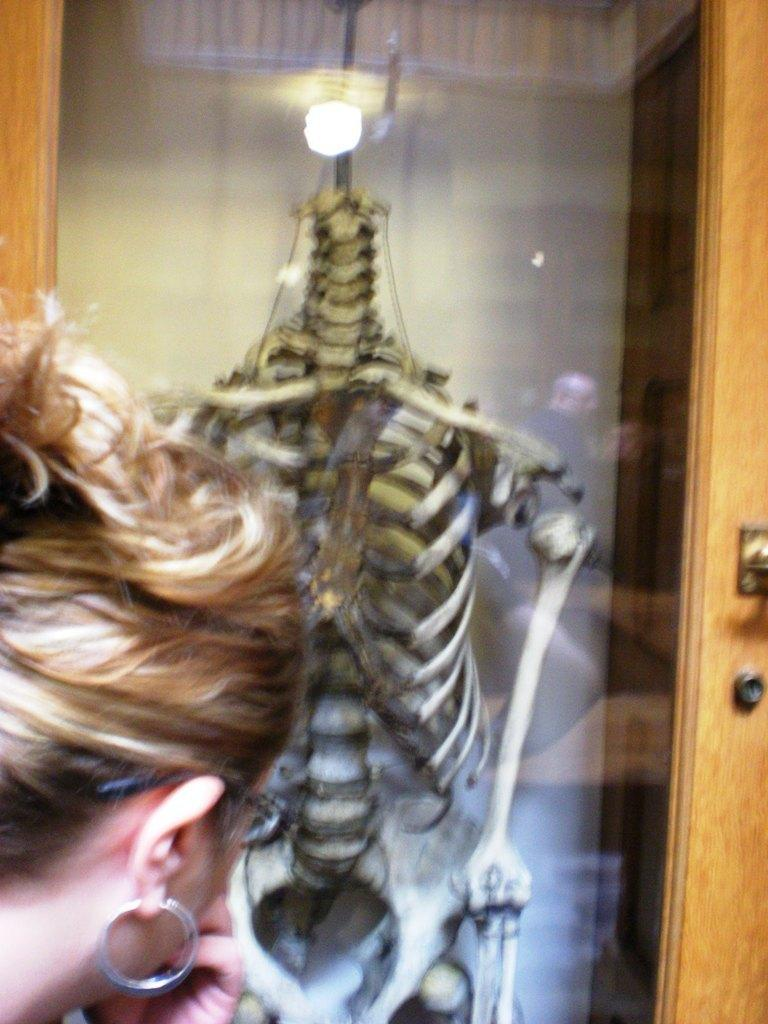Who is present in the image? There is a woman in the image. What is the woman looking at? The woman is looking at a skeleton. How is the skeleton displayed in the image? The skeleton is kept in a glass box. What type of paste is the woman using to crush the skeleton in the image? There is no paste or crushing of the skeleton in the image. The skeleton is simply displayed in a glass box. 